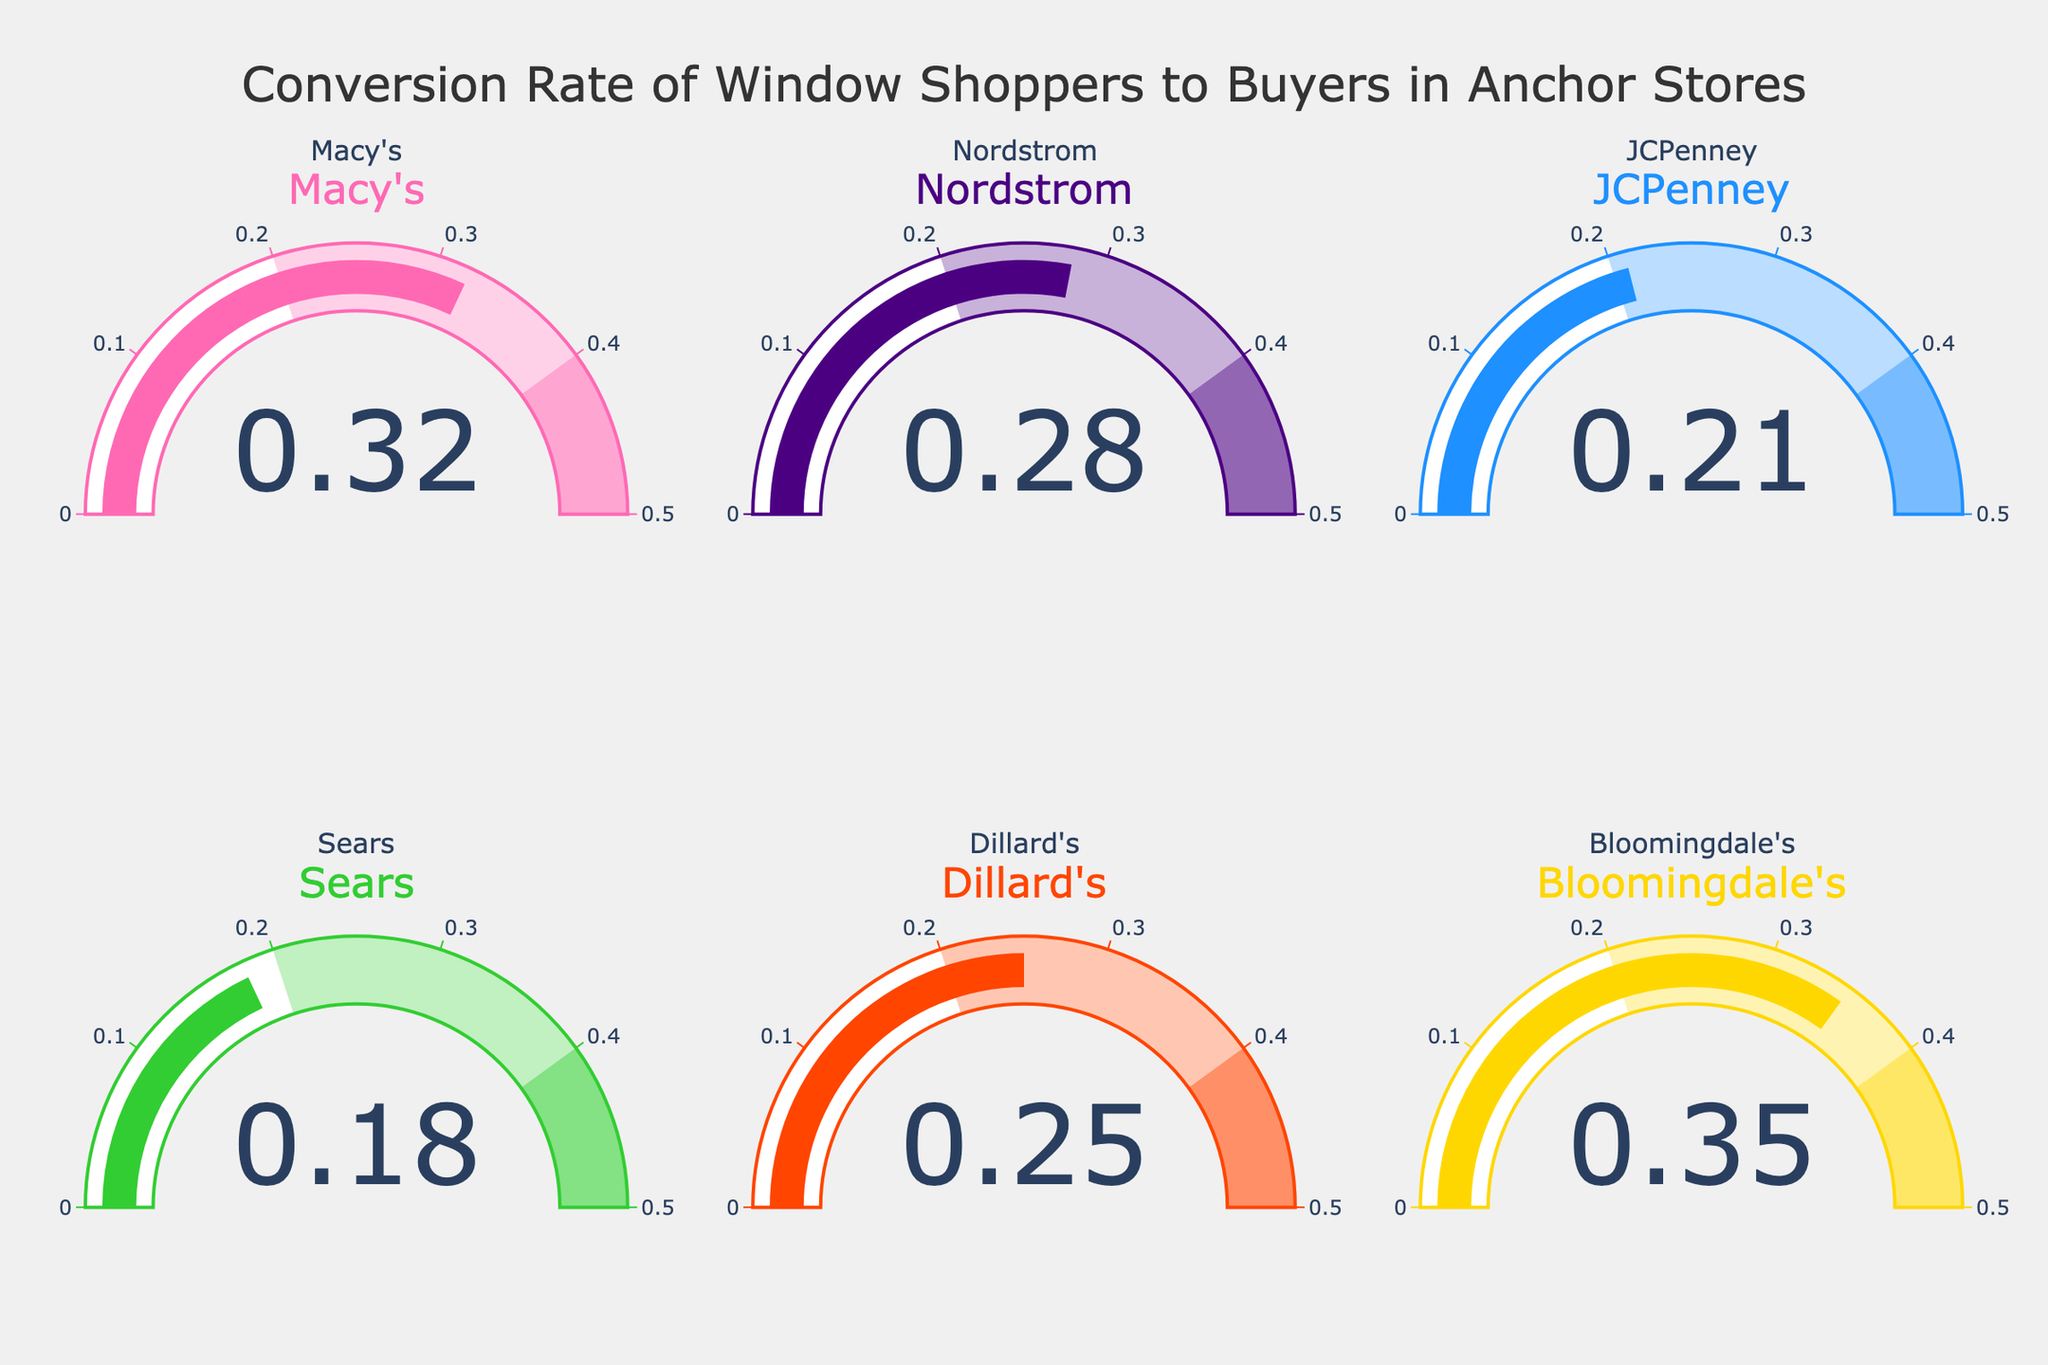What is the conversion rate for Macy's? The gauge chart for Macy's shows a value of 0.32.
Answer: 0.32 Which store has the highest conversion rate? Bloomingdale's has the highest conversion rate, as indicated by the highest value of 0.35 on the gauge chart.
Answer: Bloomingdale's What is the average conversion rate of all the stores? The conversion rates are 0.32, 0.28, 0.21, 0.18, 0.25, and 0.35. Summing these up gives 1.59. There are 6 stores, so the average is 1.59 / 6 = 0.265.
Answer: 0.265 Which store has the lowest conversion rate? The gauge chart for Sears shows the lowest conversion rate of 0.18.
Answer: Sears How much higher is Bloomingdale's conversion rate compared to Nordstrom's? Bloomingdale's conversion rate is 0.35, and Nordstrom's is 0.28. The difference is 0.35 - 0.28 = 0.07.
Answer: 0.07 What is the total sum of the conversion rates for JCPenney and Dillard's? The conversion rate for JCPenney is 0.21, and for Dillard's is 0.25. Their sum is 0.21 + 0.25 = 0.46.
Answer: 0.46 Are there any stores with a conversion rate below 0.20? Yes, Sears has a conversion rate of 0.18, which is below 0.20.
Answer: Yes Which stores have conversion rates between 0.25 and 0.35 inclusive? Dillard's with 0.25, Nordstrom with 0.28, Macy's with 0.32, and Bloomingdale's with 0.35 fall within this range.
Answer: Dillard's, Nordstrom, Macy's, Bloomingdale's What is the median conversion rate among all the stores? The sorted rates are 0.18, 0.21, 0.25, 0.28, 0.32, and 0.35. The median is the average of the third and fourth values: (0.25 + 0.28) / 2 = 0.265.
Answer: 0.265 By how much does Bloomingdale's conversion rate exceed the average of all the stores? The average conversion rate is 0.265. Bloomingdale's rate is 0.35. The difference is 0.35 - 0.265 = 0.085.
Answer: 0.085 